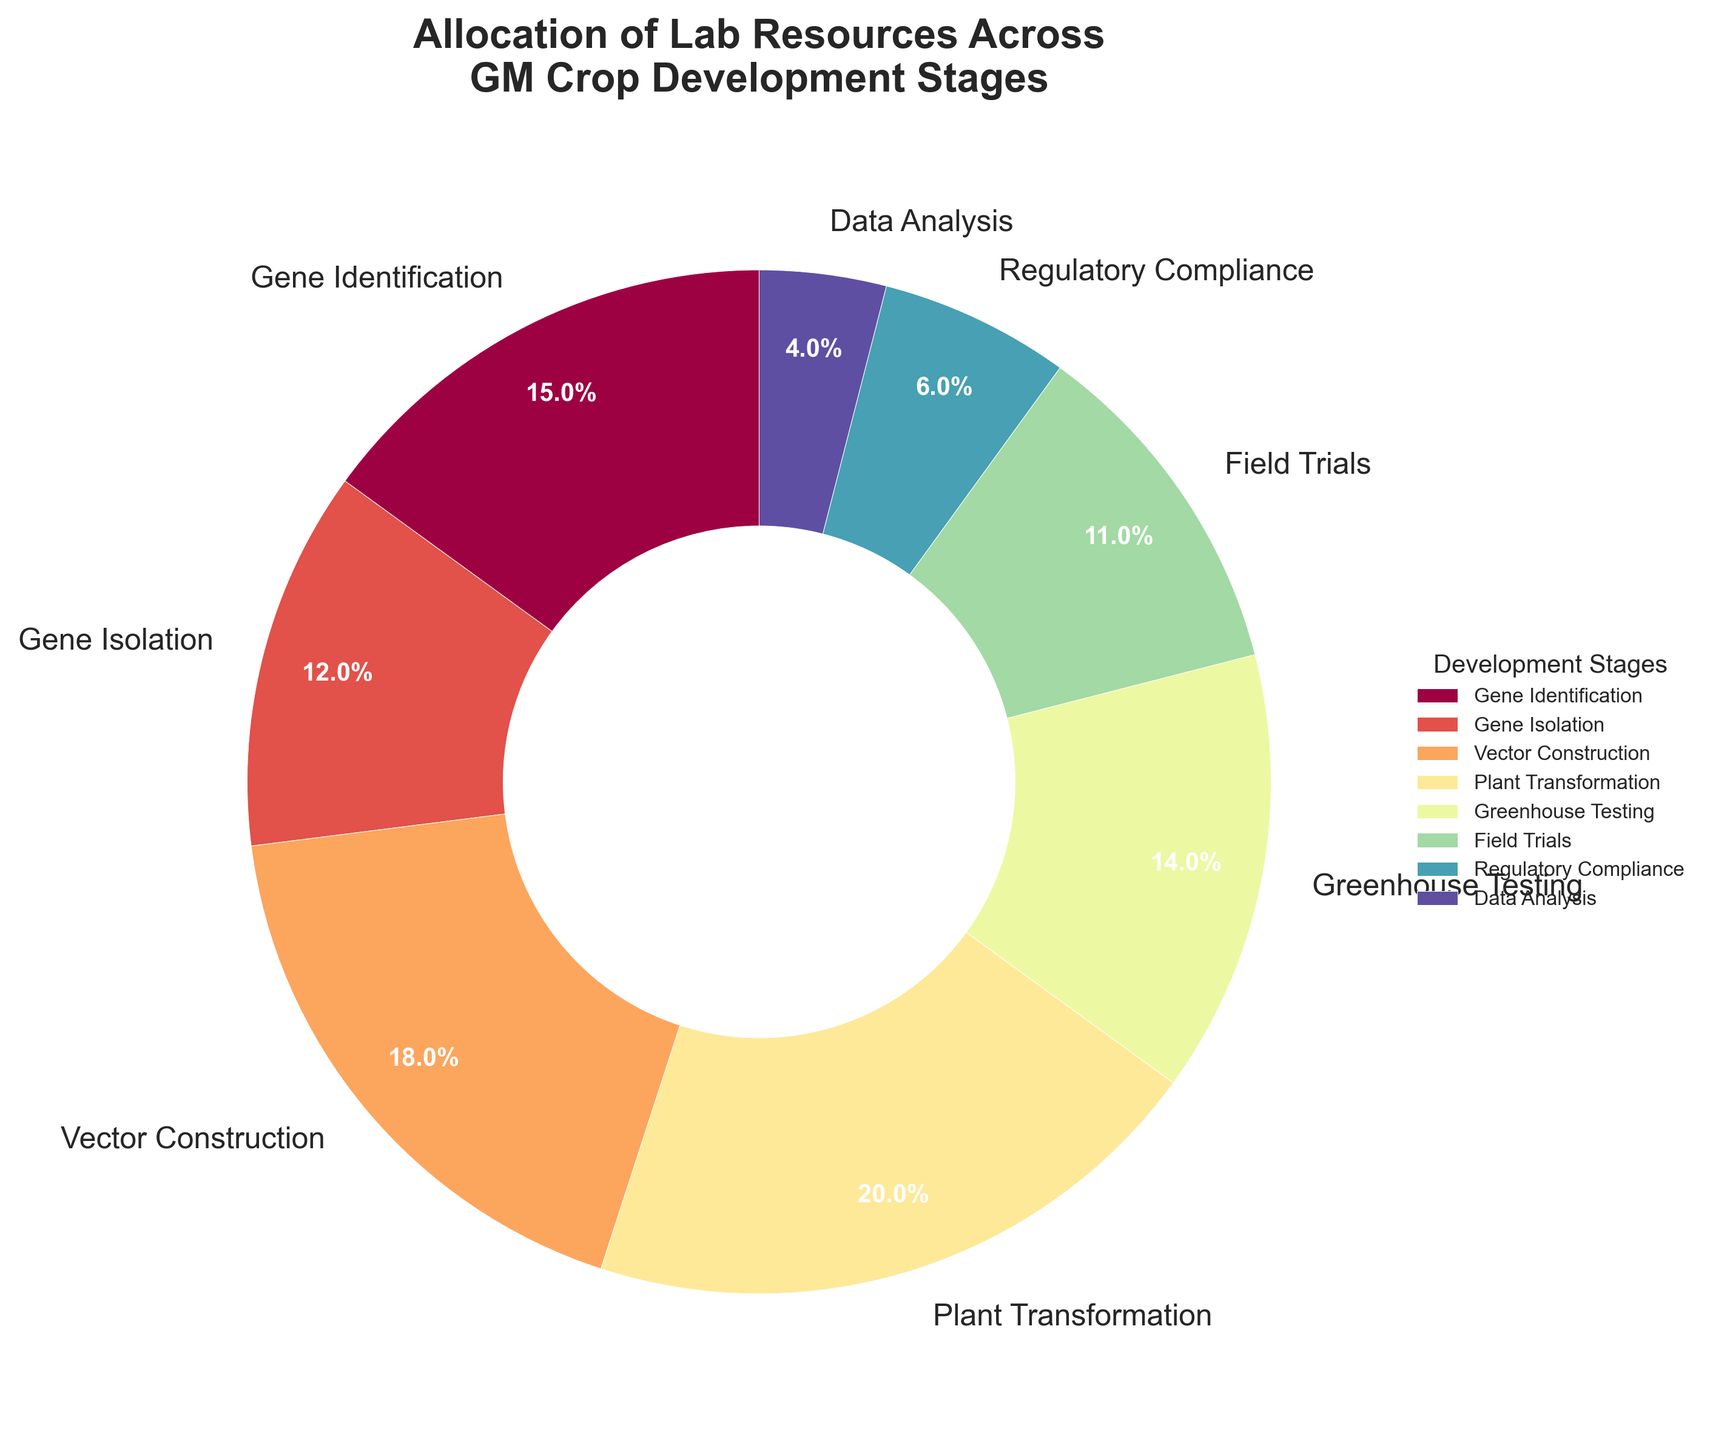What percentage of lab resources is allocated to the Plant Transformation stage? Find the "Plant Transformation" segment on the pie chart and read its associated percentage value.
Answer: 20% Which stage receives the least allocation of lab resources? Identify the segment with the smallest percentage in the pie chart. "Regulatory Compliance" has the smallest wedge, indicating it receives the least allocation.
Answer: Regulatory Compliance What is the total percentage of resources allocated to Gene Identification and Greenhouse Testing combined? Add the percentages for Gene Identification (15%) and Greenhouse Testing (14%). 15 + 14 = 29.
Answer: 29% How does the allocation for Data Analysis compare to Regulatory Compliance? Find the segments for Data Analysis and Regulatory Compliance. Data Analysis has 4%, while Regulatory Compliance has 6%. This means Data Analysis has a lower percentage.
Answer: Data Analysis has a lower allocation What proportion of resources is dedicated to the initial stages (Gene Identification, Gene Isolation, and Vector Construction) of GM crop development? Sum the percentages for Gene Identification (15%), Gene Isolation (12%), and Vector Construction (18%). 15 + 12 + 18 = 45.
Answer: 45% Is the allocation for Plant Transformation higher or lower than the combined allocation for Field Trials and Data Analysis? Add the percentages for Field Trials (11%) and Data Analysis (4%). Compare it to Plant Transformation (20%). 11 + 4 = 15, which is less than 20.
Answer: Higher What is the visual difference in the size of the wedges for Plant Transformation and Field Trials? Observe the pie chart to compare the size of the wedges. The Plant Transformation wedge is significantly larger than the Field Trials wedge.
Answer: Plant Transformation wedge is larger Which has a greater share: combined Gene Identification and Gene Isolation, or Plant Transformation alone? Add the percentages for Gene Identification (15%) and Gene Isolation (12%), then compare it to Plant Transformation. 15 + 12 = 27, which is greater than 20.
Answer: Combined Gene Identification and Gene Isolation What is the difference in allocation between the highest and lowest stages? Find the highest percentage (Plant Transformation at 20%) and the lowest percentage (Regulatory Compliance at 6%). Subtract the latter from the former. 20 - 6 = 14.
Answer: 14% Which stages together make up approximately half of the lab resource allocation? Find stages whose percentages add up to around 50%. Plant Transformation (20%), Vector Construction (18%), and one more stage like Gene Identification (15%). 20 + 18 + 15 = 53.
Answer: Plant Transformation, Vector Construction, Gene Identification 